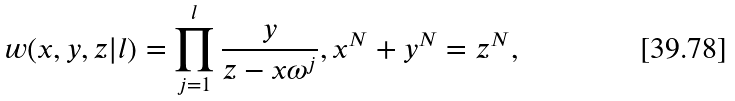Convert formula to latex. <formula><loc_0><loc_0><loc_500><loc_500>w ( x , y , z | l ) = \prod ^ { l } _ { j = 1 } \frac { y } { z - x \omega ^ { j } } , x ^ { N } + y ^ { N } = z ^ { N } ,</formula> 